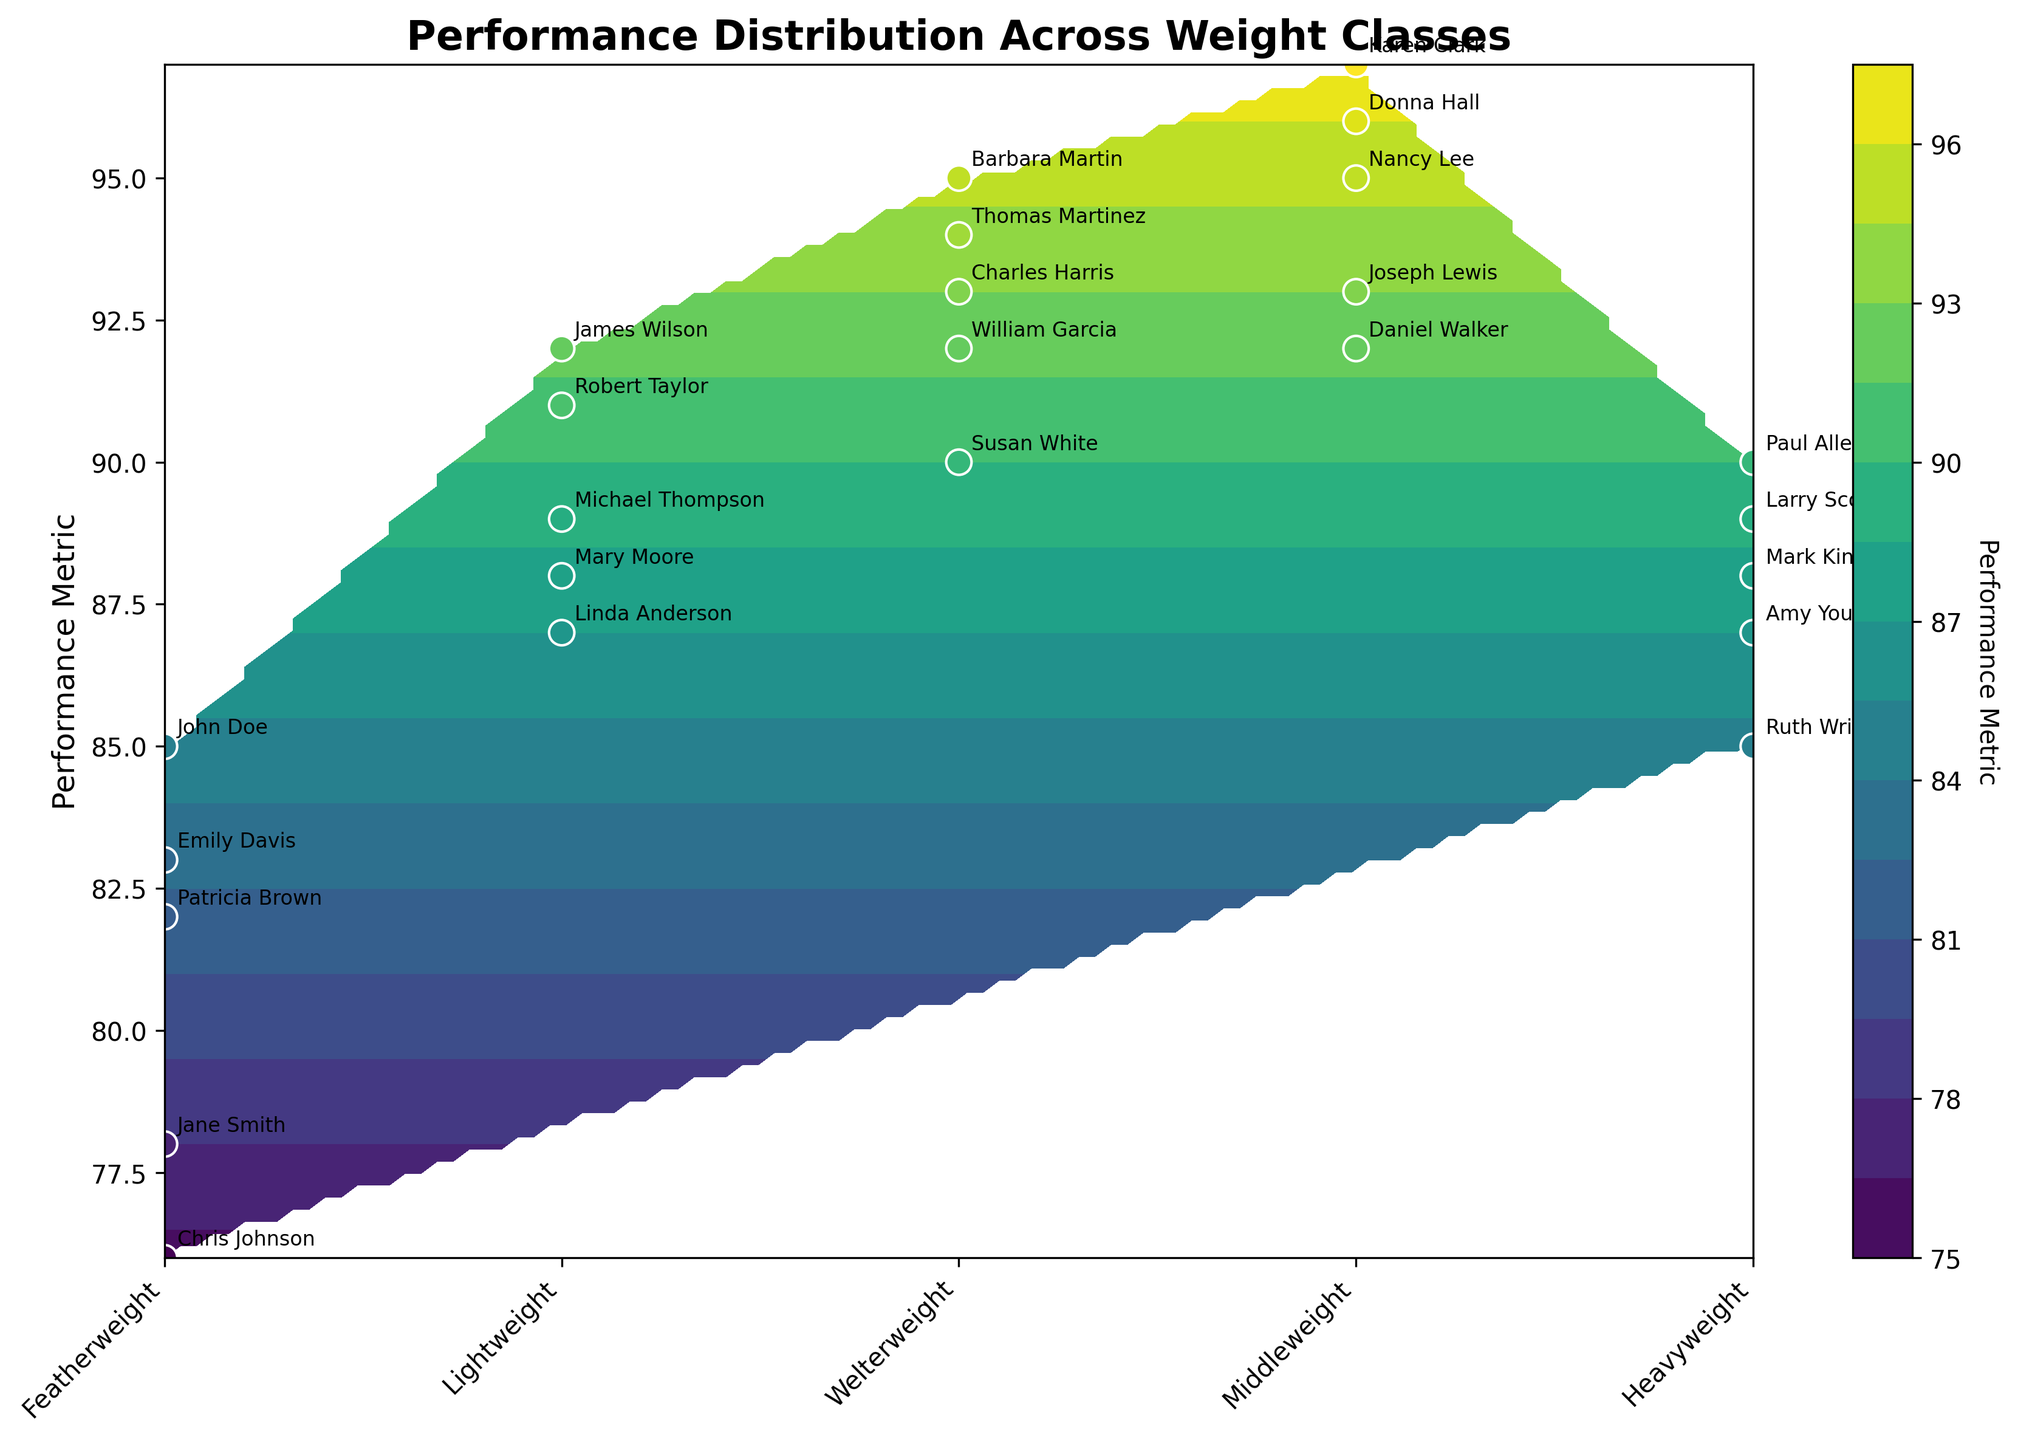What is the title of the figure? The title of the figure is located at the top and provides an overview of the displayed data. According to the figure, the title is 'Performance Distribution Across Weight Classes'.
Answer: Performance Distribution Across Weight Classes Which weight class has the highest average Performance Metric? To determine this, visually inspect the color intensity on the contour plot. The color bar indicates higher values with a lighter color. Middleweight shows the highest concentration of light colors.
Answer: Middleweight How many weight classes are depicted in the figure? The x-axis labels represent the weight classes. By counting these, we see there are five weight classes: Featherweight, Lightweight, Welterweight, Middleweight, and Heavyweight.
Answer: 5 What's the general trend of Performance Metric across weight classes? Observing the contour plot from left to right (Featherweight to Heavyweight), there is an increase in the Performance Metric, peaking at Middleweight, then a slight decrease.
Answer: Increases, peaks at Middleweight, then decreases Which weight class has the greatest variance in Performance Metric? The variance can be inferred by observing the spread of data points in each weight class. Featherweight has the most spread out data points (ranging from 76 to 85).
Answer: Featherweight Who has the highest Performance Metric and in which weight class do they compete? Identify the highest value on the y-axis and match it with the corresponding annotations. Karen Clark has the highest Performance Metric (97) and competes in the Middleweight class.
Answer: Karen Clark, Middleweight Compare the performance metrics of the top competitor in Featherweight and Lightweight classes. Locate the highest y-values for Featherweight and Lightweight classes. John Doe (85) is the top for Featherweight, and James Wilson (92) for Lightweight.
Answer: Featherweight: 85, Lightweight: 92 What is the Performance Metric range for Welterweight class? Examine the highest and lowest y-values for Welterweight competitors. The range spans from 90 (Susan White) to 95 (Barbara Martin).
Answer: 90 to 95 Which competitor has performance metrics closest to the average in the Heavyweight class? Calculate the average of the Heavyweight class (90, 87, 88, 85, 89 = 439, avg = 87.8). Larry Scott and Amy Young are closest, with metrics of 89 and 87.
Answer: Larry Scott or Amy Young What is the most common Performance Metric range in the figure? Examine the contour plot to identify the most densely populated color. Dark green color, representing metrics around the 90-92 range, appears most frequent.
Answer: 90-92 